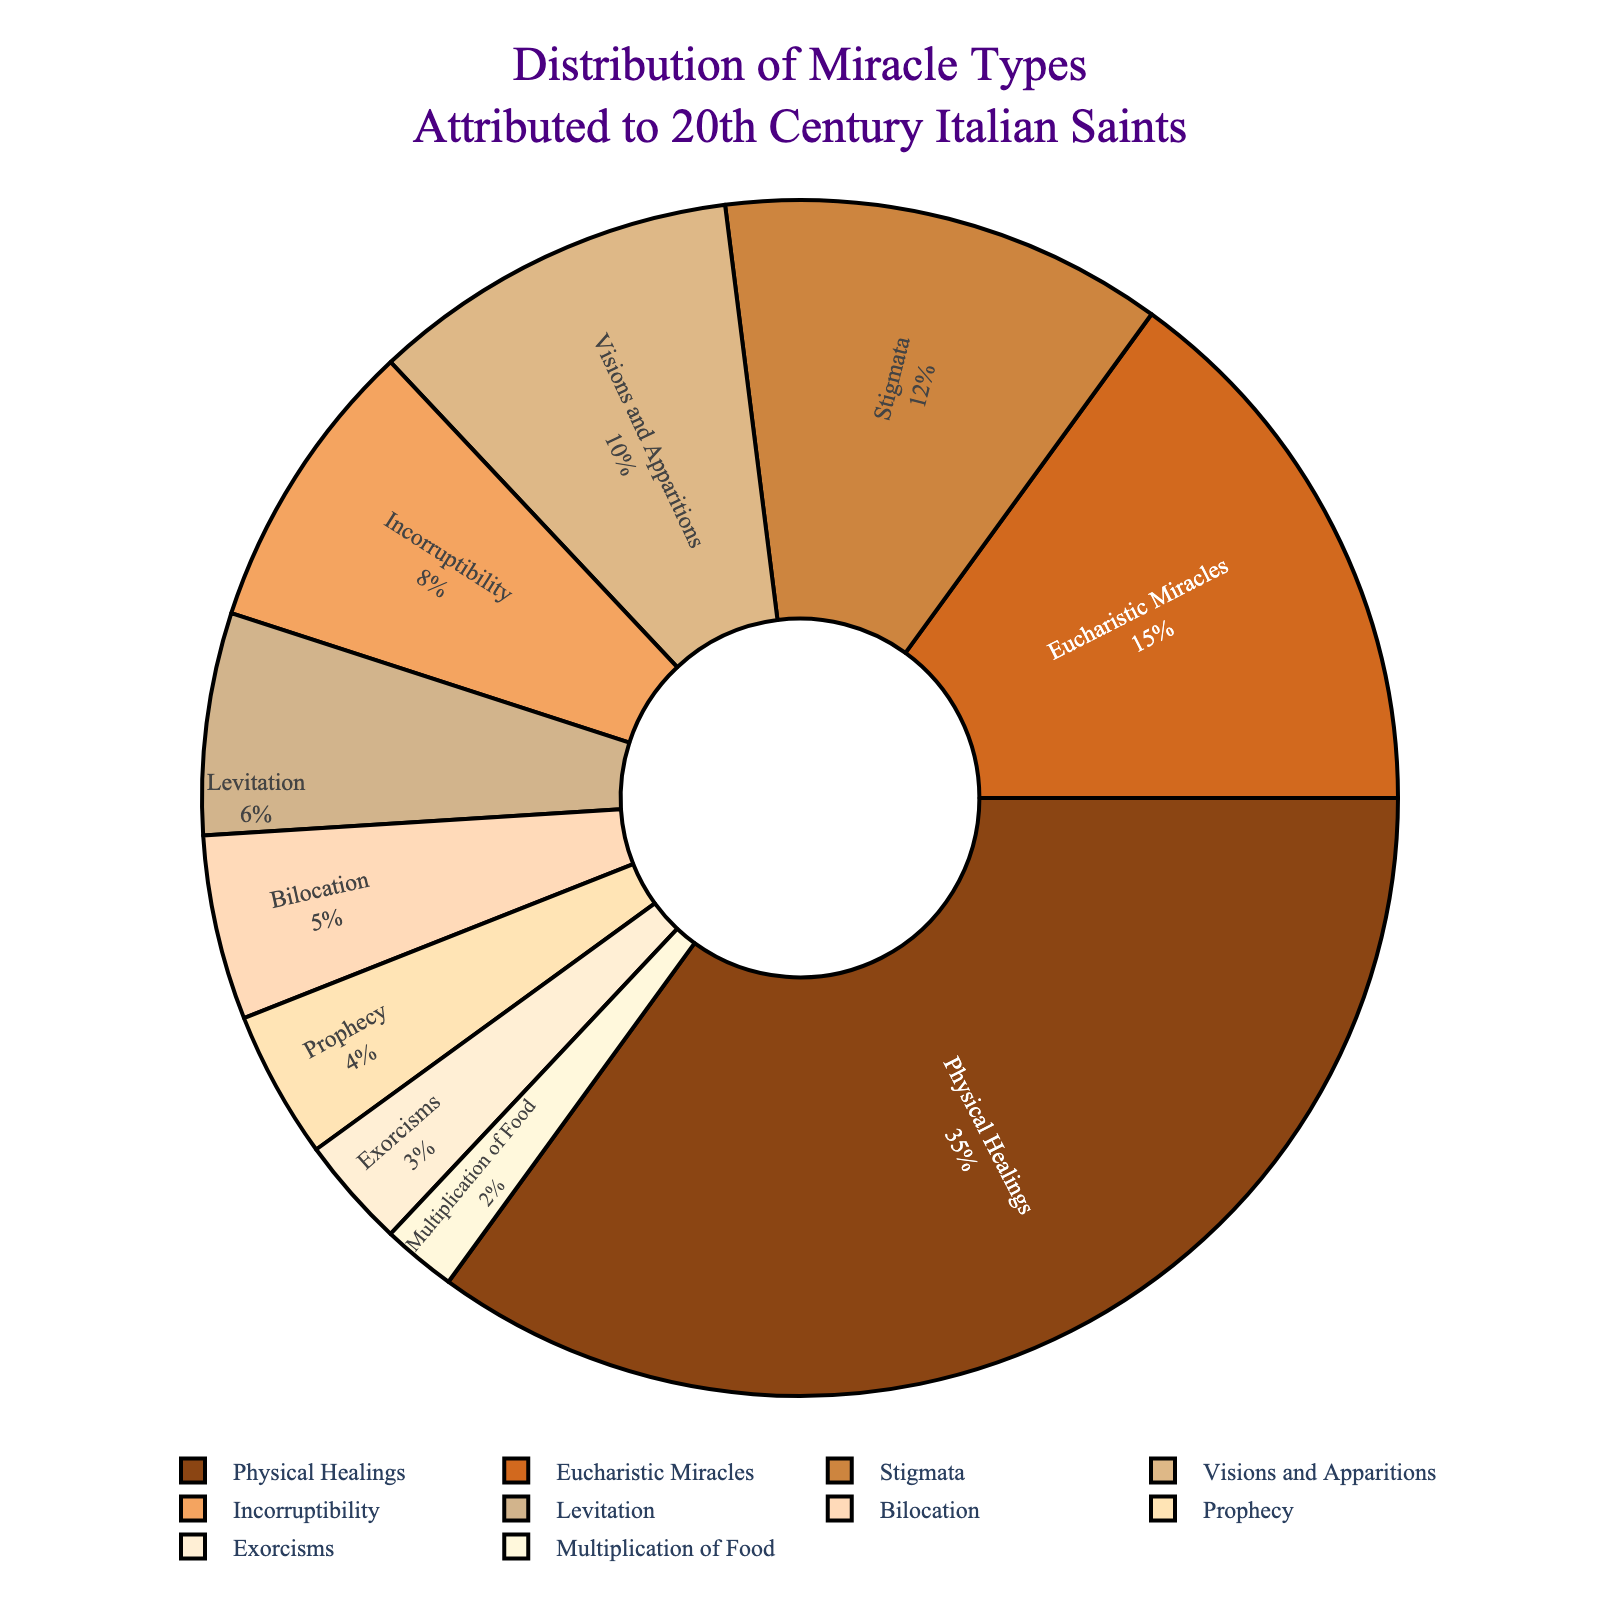Which miracle type has the highest percentage? Look for the miracle type with the largest portion in the pie chart. "Physical Healings" occupies the largest section.
Answer: Physical Healings Which miracle type accounts for the smallest portion? Identify the smallest segment in the pie chart, which is the "Multiplication of Food" segment.
Answer: Multiplication of Food How many miracle types have a percentage greater than 10%? Count the segments with percentages larger than 10%. There are four: "Physical Healings," "Eucharistic Miracles," "Stigmata," and "Visions and Apparitions."
Answer: 4 What is the total percentage of miracles related to "Eucharistic Miracles" and "Stigmata"? Add the percentages of "Eucharistic Miracles" (15%) and "Stigmata" (12%). 15 + 12 = 27.
Answer: 27% Which miracle types combined make up less than 10%? Sum the percentages of "Multiplication of Food" (2%), "Exorcisms" (3%), "Prophecy" (4%), and "Bilocation" (5%). Their combined total is 2 + 3 + 4 + 5 = 14, so only "Exorcisms" and "Multiplication of Food" individually fall into the <10% category.
Answer: Multiplication of Food, Exorcisms How much larger is the "Physical Healings" segment compared to "Prophecy"? Subtract the "Prophecy" percentage (4%) from the "Physical Healings" percentage (35%). 35 - 4 = 31.
Answer: 31% Which color represents "Levitation"? Based on the given order of colors and the position of "Levitation" in the list, determine its color in the pie chart.
Answer: #D2B48C What is the combined percentage of "Visions and Apparitions," "Incorruptibility," and "Levitation"? Add their percentages: "Visions and Apparitions" (10%), "Incorruptibility" (8%), and "Levitation" (6%). 10 + 8 + 6 = 24.
Answer: 24% Which is more frequent, "Stigmata" or "Incorruptibility"? Compare the percentages of "Stigmata" (12%) and "Incorruptibility" (8%). 12 > 8.
Answer: Stigmata Is the percentage of "Bilocation" more or less than that of "Levitation"? Compare the percentages of "Bilocation" (5%) and "Levitation" (6%). 5 < 6.
Answer: Less 